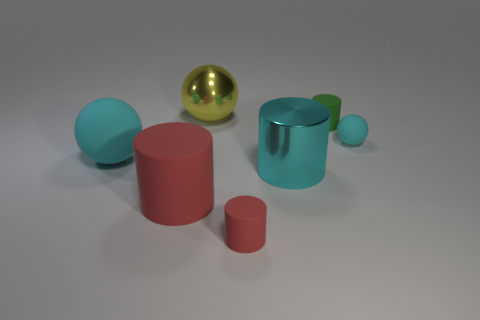Subtract all big matte cylinders. How many cylinders are left? 3 Subtract all balls. How many objects are left? 4 Add 2 tiny gray metallic things. How many objects exist? 9 Subtract 2 spheres. How many spheres are left? 1 Subtract 0 yellow blocks. How many objects are left? 7 Subtract all cyan cylinders. Subtract all gray blocks. How many cylinders are left? 3 Subtract all gray cubes. How many green cylinders are left? 1 Subtract all metal cylinders. Subtract all red rubber cylinders. How many objects are left? 4 Add 1 small red matte cylinders. How many small red matte cylinders are left? 2 Add 2 large matte objects. How many large matte objects exist? 4 